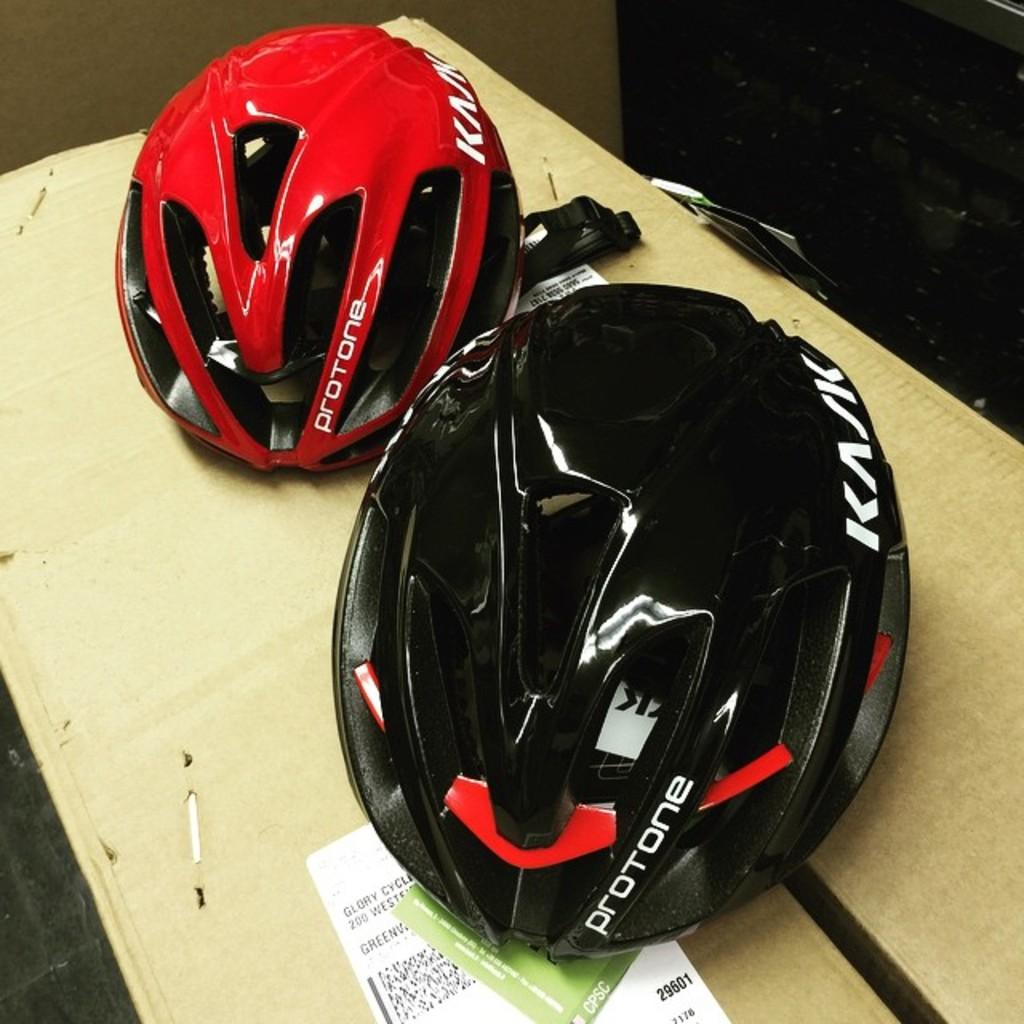What objects are on the cardboard box in the image? There are helmets on a cardboard box in the image. Can you describe the background of the image? There are objects visible in the background of the image. What direction are the helmets facing in the image? The direction the helmets are facing cannot be determined from the image, as they are on a cardboard box and not facing any specific direction. 